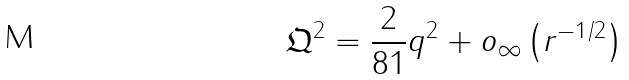<formula> <loc_0><loc_0><loc_500><loc_500>\mathfrak { Q } ^ { 2 } = \frac { 2 } { 8 1 } q ^ { 2 } + o _ { \infty } \left ( r ^ { - 1 / 2 } \right )</formula> 